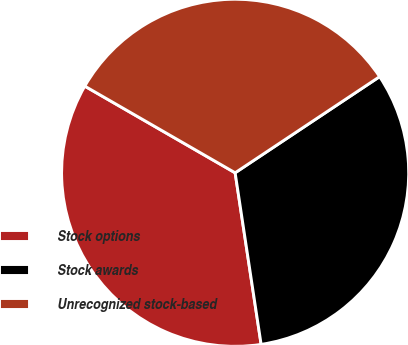<chart> <loc_0><loc_0><loc_500><loc_500><pie_chart><fcel>Stock options<fcel>Stock awards<fcel>Unrecognized stock-based<nl><fcel>35.71%<fcel>31.95%<fcel>32.33%<nl></chart> 